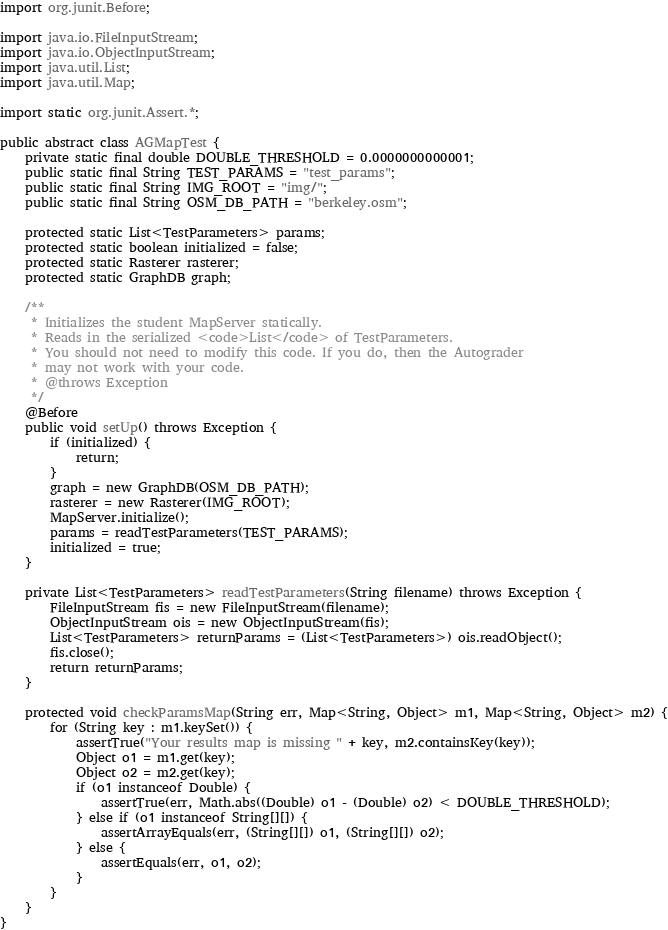<code> <loc_0><loc_0><loc_500><loc_500><_Java_>import org.junit.Before;

import java.io.FileInputStream;
import java.io.ObjectInputStream;
import java.util.List;
import java.util.Map;

import static org.junit.Assert.*;

public abstract class AGMapTest {
    private static final double DOUBLE_THRESHOLD = 0.0000000000001;
    public static final String TEST_PARAMS = "test_params";
    public static final String IMG_ROOT = "img/";
    public static final String OSM_DB_PATH = "berkeley.osm";

    protected static List<TestParameters> params;
    protected static boolean initialized = false;
    protected static Rasterer rasterer;
    protected static GraphDB graph;

    /**
     * Initializes the student MapServer statically.
     * Reads in the serialized <code>List</code> of TestParameters.
     * You should not need to modify this code. If you do, then the Autograder
     * may not work with your code.
     * @throws Exception
     */
    @Before
    public void setUp() throws Exception {
        if (initialized) {
            return;
        }
        graph = new GraphDB(OSM_DB_PATH);
        rasterer = new Rasterer(IMG_ROOT);
        MapServer.initialize();
        params = readTestParameters(TEST_PARAMS);
        initialized = true;
    }

    private List<TestParameters> readTestParameters(String filename) throws Exception {
        FileInputStream fis = new FileInputStream(filename);
        ObjectInputStream ois = new ObjectInputStream(fis);
        List<TestParameters> returnParams = (List<TestParameters>) ois.readObject();
        fis.close();
        return returnParams;
    }

    protected void checkParamsMap(String err, Map<String, Object> m1, Map<String, Object> m2) {
        for (String key : m1.keySet()) {
            assertTrue("Your results map is missing " + key, m2.containsKey(key));
            Object o1 = m1.get(key);
            Object o2 = m2.get(key);
            if (o1 instanceof Double) {
                assertTrue(err, Math.abs((Double) o1 - (Double) o2) < DOUBLE_THRESHOLD);
            } else if (o1 instanceof String[][]) {
                assertArrayEquals(err, (String[][]) o1, (String[][]) o2);
            } else {
                assertEquals(err, o1, o2);
            }
        }
    }
}
</code> 